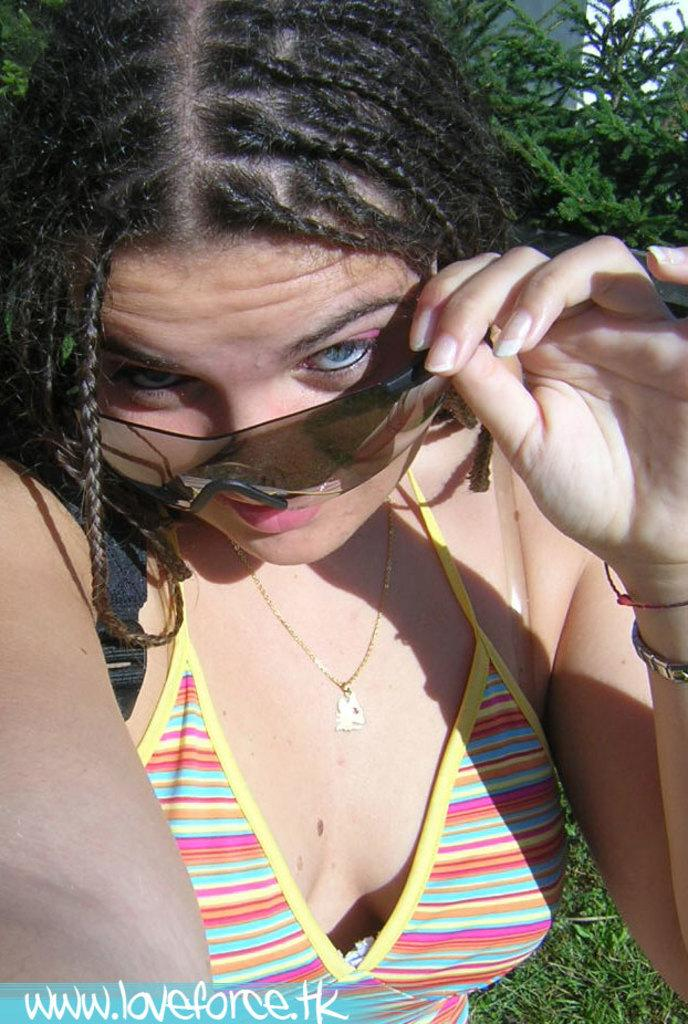Who is present in the image? There is a woman in the image. What is the woman wearing? The woman is wearing clothes, a neck chain, a bracelet, and goggles. What can be seen in the background of the image? There is grass and a tree in the image. Is there any additional information about the image itself? Yes, there is a watermark in the image. What time of day is depicted in the image? The provided facts do not mention the time of day, so it cannot be determined from the image. How many family members are present in the image? There is no information about family members in the image; only the woman is mentioned. 